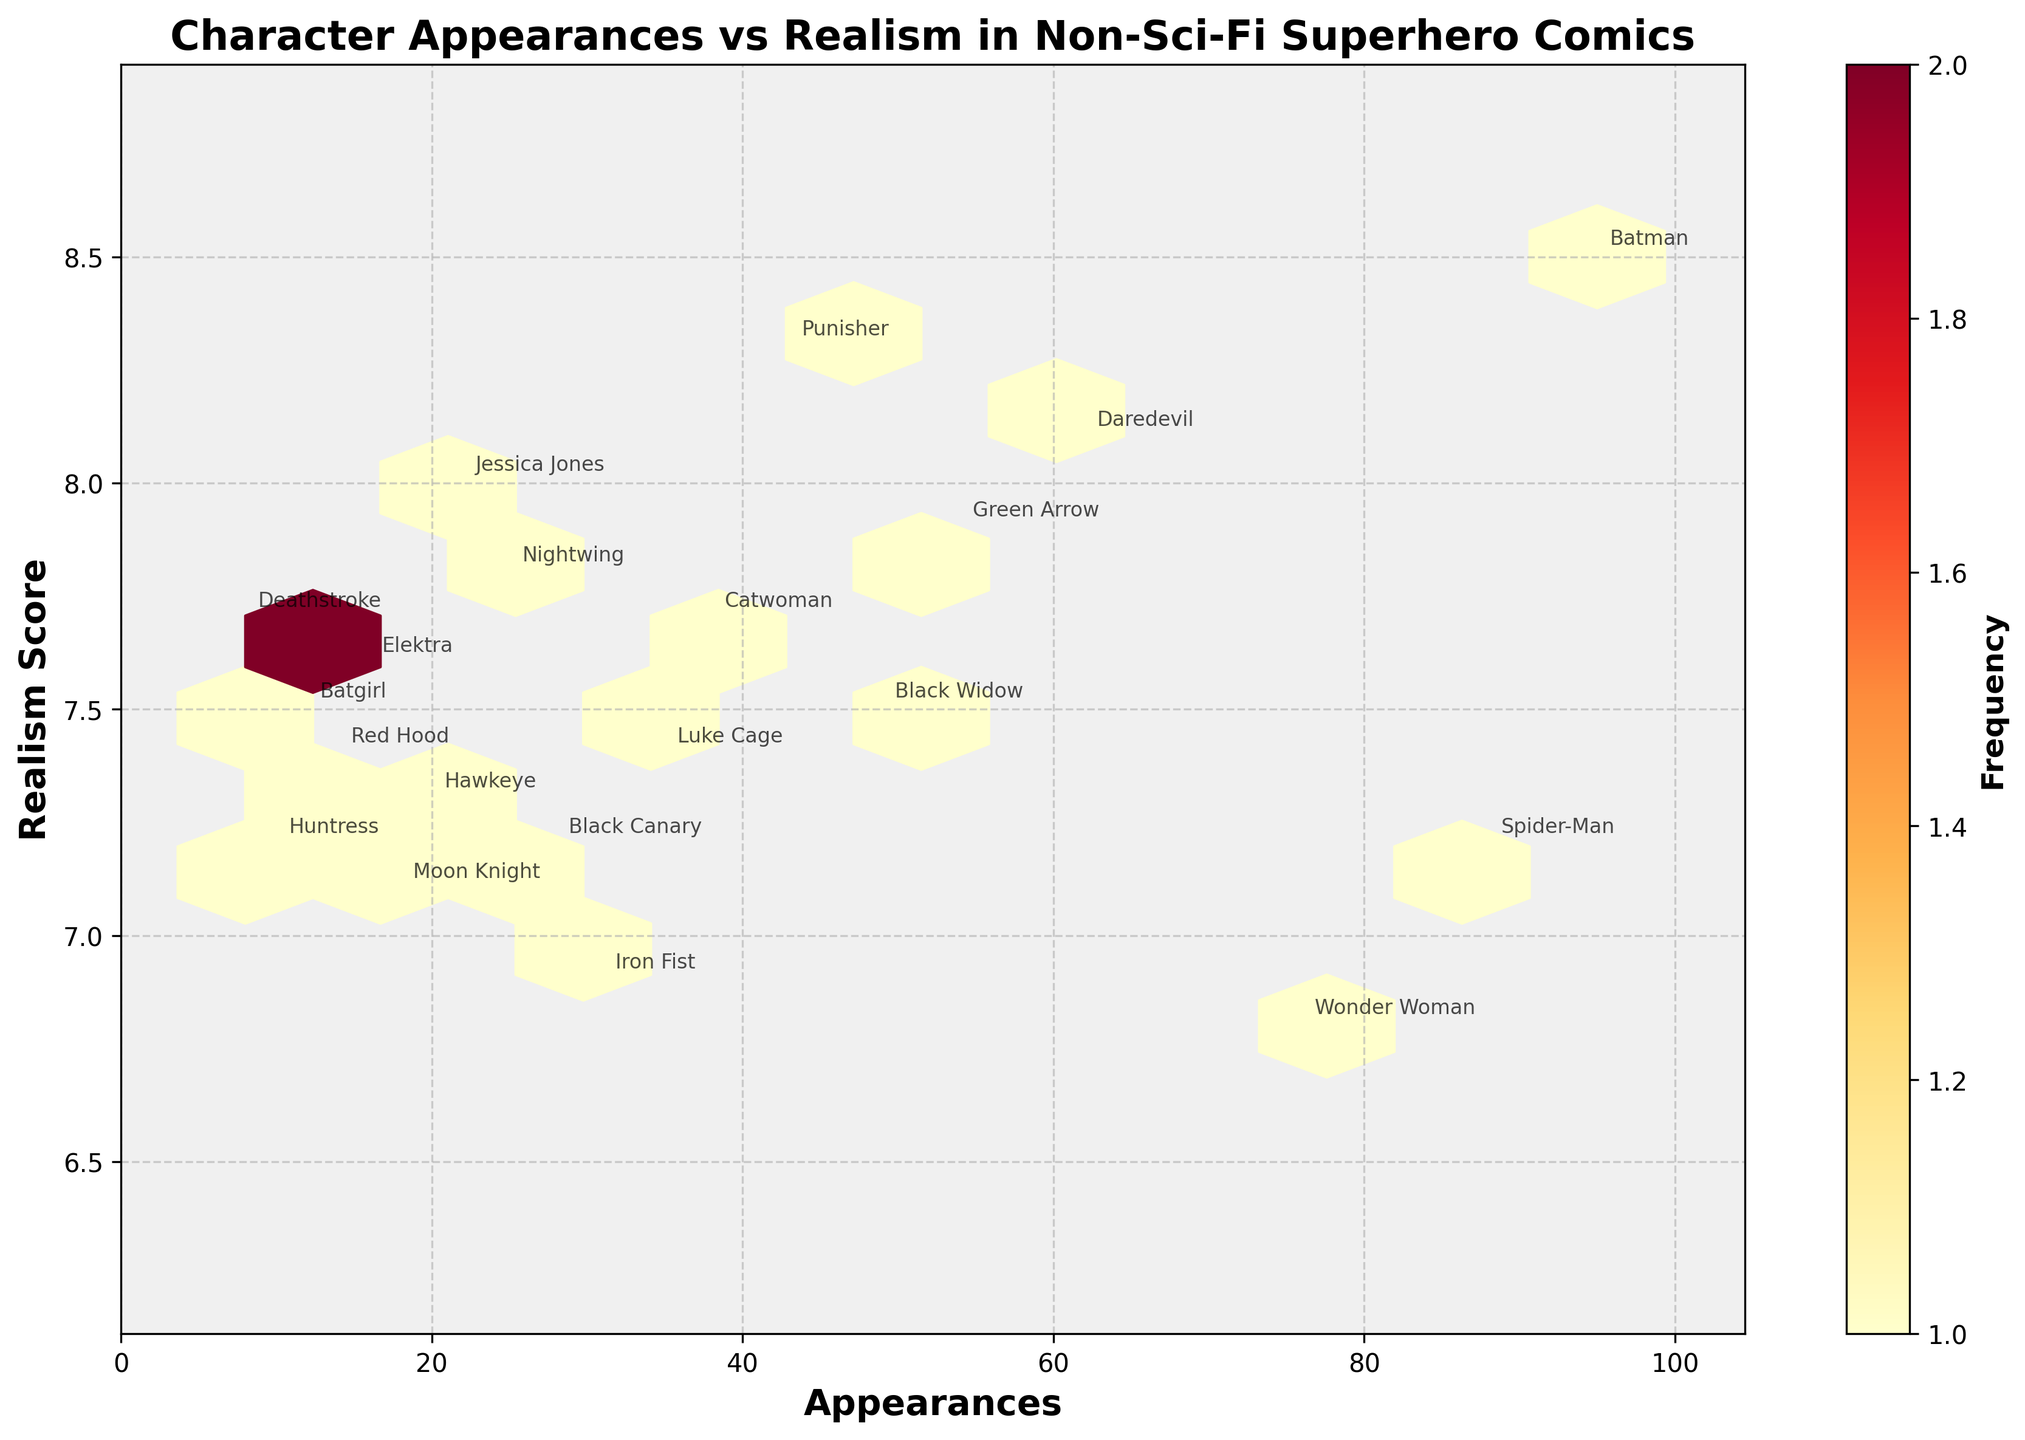How many characters have an appearance count greater than 50? To find this, locate the appearance count axis (x-axis) and count the annotations above the 50 mark. Batman, Spider-Man, Wonder Woman, Daredevil, and Green Arrow all meet this criterion. This sums to 5 characters.
Answer: 5 What's the range of Realism Scores depicted in the plot? Locate the realism score range on the y-axis. The minimum value appears to be around 6.8, and the maximum is close to 8.5. Thus, the range is 8.5 - 6.8 = 1.7.
Answer: 1.7 Which character in the plot has the highest Realism Score and how many appearances do they have? The character with the highest Realism Score is Batman, with a Realism Score of 8.5. Batman also appears to have 95 appearances, as annotated on the plot.
Answer: Batman, 95 How many characters have a Realism Score less than 7.0? By observing the y-axis and counting annotations below the 7.0 mark, we find that Wonder Woman, Iron Fist, and Moon Knight have Realism Scores less than 7.0. This sums to 3 characters.
Answer: 3 Compare Batman and Spider-Man: Who has more appearances, and do they have similar Realism Scores? Batman and Spider-Man's annotations are close to each other. Batman has 95 appearances and a Realism Score of 8.5, while Spider-Man has 88 appearances and a Realism Score of 7.2. Batman has more appearances, and their Realism Scores are not similar.
Answer: Batman has more appearances, different Realism Scores Which hexagon has the highest frequency and what does that represent visually? The color intensity indicates frequency. Locate the darkest hexagon. Since hexagon bins each represent areas of similar data, the darkest hexagon corresponds to the most popular appearance count and Realism Score in its range. Although precise values are challenging to extract without the exact color-to-value map, the highest frequency hexagon visually represents high clustering of appearances and Realism Scores around a certain point.
Answer: Darkest hexagon, highest frequency What is the typical range of appearances for characters with a Realism Score between 7 and 8? Focus on the vertical band between Realism Scores of 7 and 8. Annotated characters within this band include Spider-Man, Wonder Woman, Iron Fist, Moon Knight, etc. Their appearance ranges from 18 to 88.
Answer: 18 to 88 Which character has the lowest number of appearances and what is their Realism Score? Find the character annotation closest to the origin (0,0), which is Deathstroke, with 8 appearances and a Realism Score of 7.7.
Answer: Deathstroke, 8 appearances, 7.7 Realism Score 